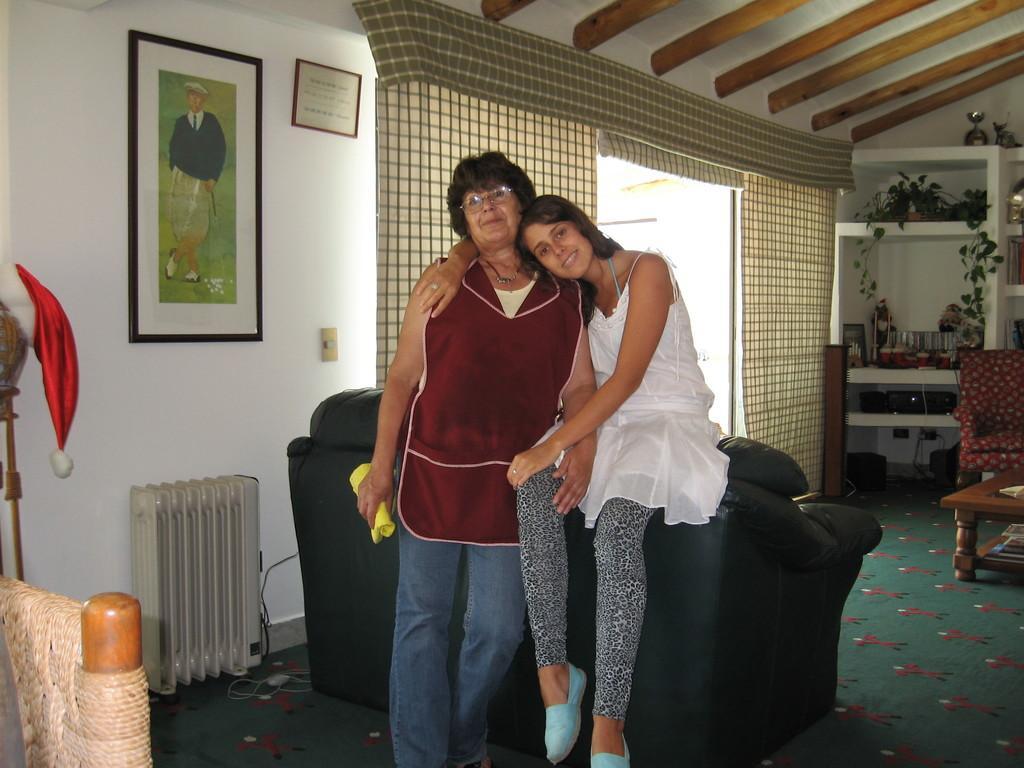Can you describe this image briefly? In this image there are two persons smiling , there is a person sitting on the couch and holding another person, there are frames attached to the wall, Santa Claus hat , some objects in the shelves, there are curtains, chairs, table ,carpet. 